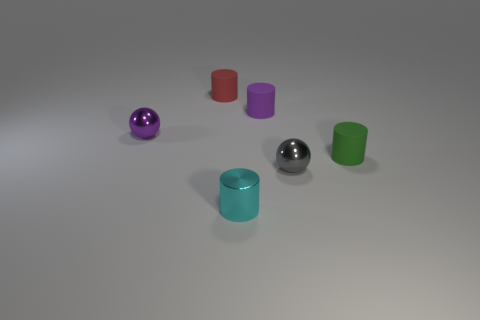There is a small purple object that is made of the same material as the small cyan thing; what shape is it? The small purple object shares its glossy, solid appearance with the small cyan object, indicating they are made from a similar material. The shape of the purple object is a sphere. 